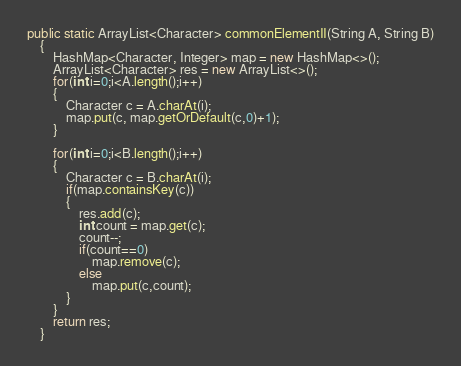Convert code to text. <code><loc_0><loc_0><loc_500><loc_500><_Java_>public static ArrayList<Character> commonElementII(String A, String B)
    {
        HashMap<Character, Integer> map = new HashMap<>();
        ArrayList<Character> res = new ArrayList<>();
        for(int i=0;i<A.length();i++)
        {
            Character c = A.charAt(i);
            map.put(c, map.getOrDefault(c,0)+1);
        }

        for(int i=0;i<B.length();i++)
        {
            Character c = B.charAt(i);
            if(map.containsKey(c))
            {
                res.add(c);
                int count = map.get(c);
                count--;
                if(count==0)
                    map.remove(c);
                else
                    map.put(c,count);
            }
        }
        return res;
    }
</code> 